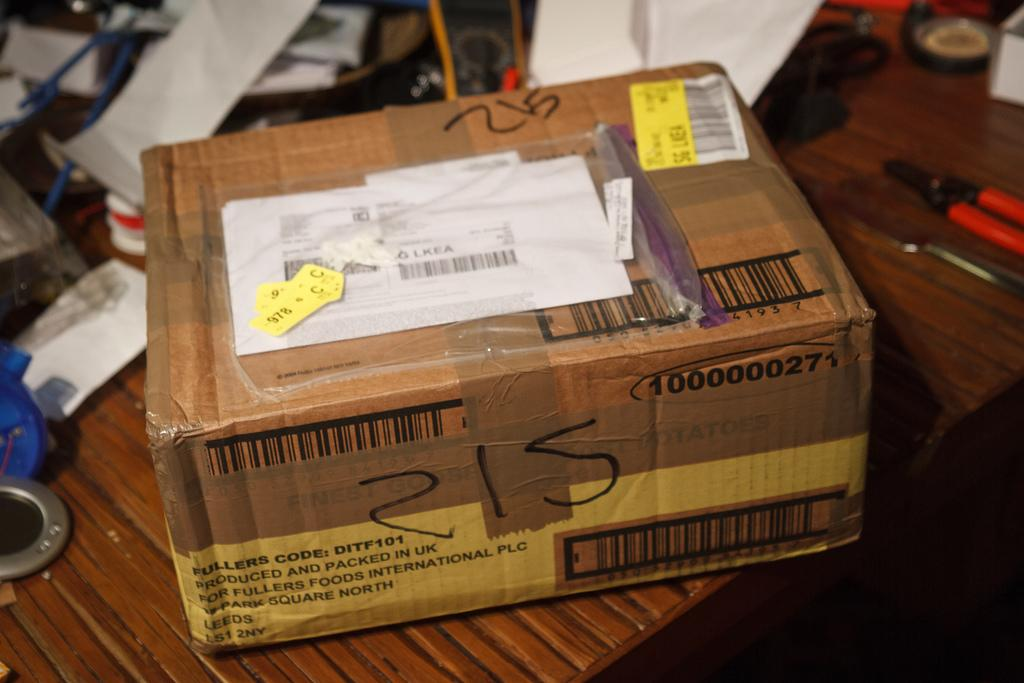<image>
Describe the image concisely. Brown box on a table with the number 215 on it. 